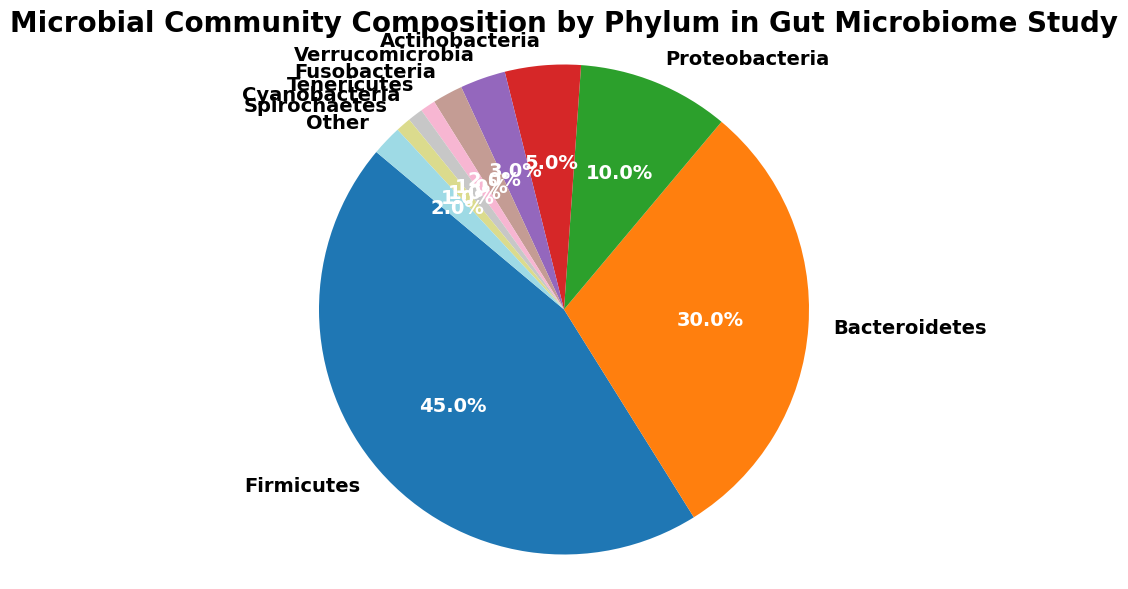What percentage of the microbial community is represented by Firmicutes and Bacteroidetes combined? To find the combined percentage of Firmicutes and Bacteroidetes, sum their individual percentages: 45% (Firmicutes) + 30% (Bacteroidetes) = 75%.
Answer: 75% How much larger is the percentage of Proteobacteria compared to Verrucomicrobia? To find the difference in percentage between Proteobacteria and Verrucomicrobia, subtract Verrucomicrobia's percentage from that of Proteobacteria: 10% (Proteobacteria) - 3% (Verrucomicrobia) = 7%.
Answer: 7% Which phylum occupies the largest portion of the pie chart? To determine the largest portion, compare the percentages of each phylum. Firmicutes has the highest percentage at 45%.
Answer: Firmicutes Compare the sum of percentages of the two smallest phyla to the percentage of Actinobacteria. Which is larger and by how much? First, identify the two smallest phyla: Tenericutes and Cyanobacteria (1% each). Sum their percentages: 1% (Tenericutes) + 1% (Cyanobacteria) = 2%. Then compare this to Actinobacteria's percentage, which is 5%. The difference is 5% - 2% = 3%. Actinobacteria is larger by 3%.
Answer: Actinobacteria is larger by 3% What is the combined percentage of all phyla that occupy less than 5% of the community each? Identify all phyla with less than 5% representation: Proteobacteria (10%), Actinobacteria (5%), Verrucomicrobia (3%), Fusobacteria (2%), Tenericutes (1%), Cyanobacteria (1%), and Spirochaetes (1%). Now sum these percentages: 5% (Actinobacteria) + 3% (Verrucomicrobia) + 2% (Fusobacteria) + 1% (Tenericutes) + 1% (Cyanobacteria) + 1% (Spirochaetes) + 2% (Other) = 10%.
Answer: 10% Is the sum of the percentages of Verrucomicrobia and Fusobacteria greater than the percentage of Proteobacteria? Sum the percentages of Verrucomicrobia and Fusobacteria: 3% (Verrucomicrobia) + 2% (Fusobacteria) = 5%. Compare this to the percentage of Proteobacteria, which is 10%. 5% is less than 10%.
Answer: No Which phylum appears in the smallest segment of the pie chart? To determine the smallest segment, look for the phylum with the smallest percentage. Tenericutes, Cyanobacteria, and Spirochaetes each occupy 1%, but they are equal and collectively the smallest.
Answer: Tenericutes, Cyanobacteria, and Spirochaetes If the 'Other' category was removed, by how much would the percentage of Firmicutes increase relative to the new total? Removing 'Other' (2%) means the total is now 98%. Firmicutes would then constitute (45% / 98%) * 100% = approximately 45.92% of the new total.
Answer: Approx. 45.92% How much larger is the sum of Firmicutes and Bacteroidetes compared to all other phyla combined? First, sum Firmicutes and Bacteroidetes: 45% + 30% = 75%. Next, sum the rest: 100% - 75% = 25%. Then, find the difference: 75% - 25% = 50%.
Answer: 50% 